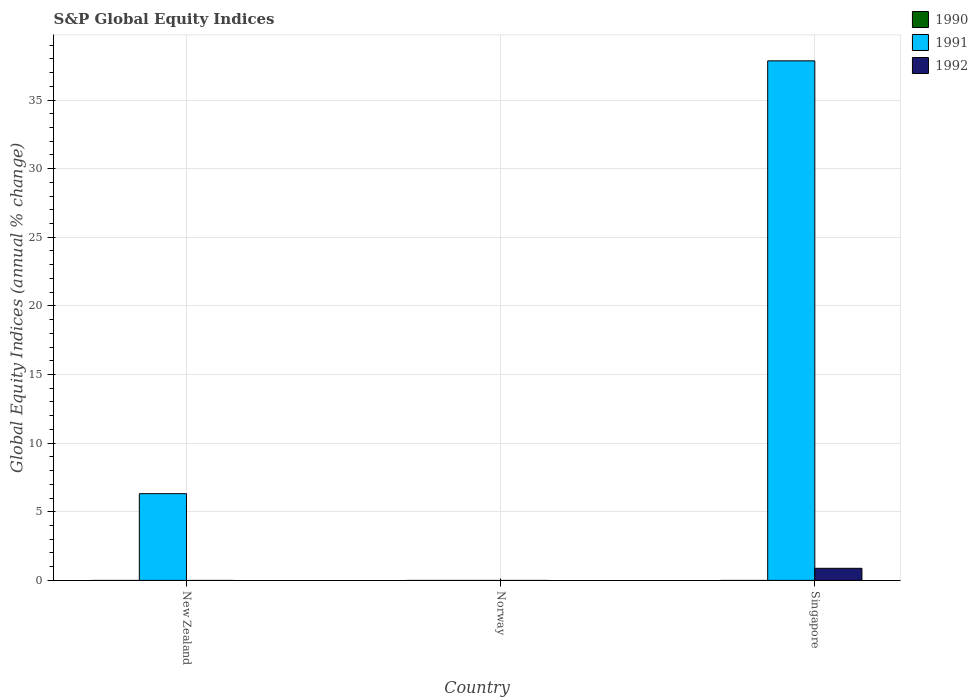How many different coloured bars are there?
Offer a very short reply. 2. Are the number of bars on each tick of the X-axis equal?
Keep it short and to the point. No. How many bars are there on the 3rd tick from the left?
Offer a very short reply. 2. How many bars are there on the 3rd tick from the right?
Offer a very short reply. 1. What is the label of the 2nd group of bars from the left?
Provide a short and direct response. Norway. In how many cases, is the number of bars for a given country not equal to the number of legend labels?
Your answer should be compact. 3. Across all countries, what is the maximum global equity indices in 1992?
Your answer should be compact. 0.88. In which country was the global equity indices in 1991 maximum?
Provide a succinct answer. Singapore. What is the total global equity indices in 1991 in the graph?
Your answer should be compact. 44.17. What is the difference between the global equity indices in 1991 in New Zealand and the global equity indices in 1990 in Singapore?
Offer a terse response. 6.32. What is the average global equity indices in 1992 per country?
Your answer should be very brief. 0.29. What is the difference between the global equity indices of/in 1992 and global equity indices of/in 1991 in Singapore?
Your answer should be compact. -36.97. What is the difference between the highest and the lowest global equity indices in 1992?
Your response must be concise. 0.88. In how many countries, is the global equity indices in 1992 greater than the average global equity indices in 1992 taken over all countries?
Provide a succinct answer. 1. Is the sum of the global equity indices in 1991 in New Zealand and Singapore greater than the maximum global equity indices in 1990 across all countries?
Provide a short and direct response. Yes. Are all the bars in the graph horizontal?
Give a very brief answer. No. Are the values on the major ticks of Y-axis written in scientific E-notation?
Give a very brief answer. No. Does the graph contain grids?
Ensure brevity in your answer.  Yes. Where does the legend appear in the graph?
Offer a very short reply. Top right. How many legend labels are there?
Offer a very short reply. 3. How are the legend labels stacked?
Give a very brief answer. Vertical. What is the title of the graph?
Provide a succinct answer. S&P Global Equity Indices. Does "1972" appear as one of the legend labels in the graph?
Keep it short and to the point. No. What is the label or title of the Y-axis?
Make the answer very short. Global Equity Indices (annual % change). What is the Global Equity Indices (annual % change) of 1991 in New Zealand?
Provide a succinct answer. 6.32. What is the Global Equity Indices (annual % change) in 1992 in New Zealand?
Your answer should be very brief. 0. What is the Global Equity Indices (annual % change) of 1990 in Norway?
Provide a succinct answer. 0. What is the Global Equity Indices (annual % change) in 1991 in Norway?
Offer a terse response. 0. What is the Global Equity Indices (annual % change) of 1992 in Norway?
Your answer should be compact. 0. What is the Global Equity Indices (annual % change) of 1991 in Singapore?
Ensure brevity in your answer.  37.85. What is the Global Equity Indices (annual % change) in 1992 in Singapore?
Keep it short and to the point. 0.88. Across all countries, what is the maximum Global Equity Indices (annual % change) in 1991?
Provide a succinct answer. 37.85. Across all countries, what is the maximum Global Equity Indices (annual % change) in 1992?
Your response must be concise. 0.88. What is the total Global Equity Indices (annual % change) of 1990 in the graph?
Your answer should be very brief. 0. What is the total Global Equity Indices (annual % change) in 1991 in the graph?
Make the answer very short. 44.17. What is the total Global Equity Indices (annual % change) in 1992 in the graph?
Make the answer very short. 0.88. What is the difference between the Global Equity Indices (annual % change) of 1991 in New Zealand and that in Singapore?
Your answer should be compact. -31.53. What is the difference between the Global Equity Indices (annual % change) of 1991 in New Zealand and the Global Equity Indices (annual % change) of 1992 in Singapore?
Offer a terse response. 5.44. What is the average Global Equity Indices (annual % change) of 1990 per country?
Provide a short and direct response. 0. What is the average Global Equity Indices (annual % change) of 1991 per country?
Provide a short and direct response. 14.72. What is the average Global Equity Indices (annual % change) of 1992 per country?
Your answer should be compact. 0.29. What is the difference between the Global Equity Indices (annual % change) in 1991 and Global Equity Indices (annual % change) in 1992 in Singapore?
Keep it short and to the point. 36.97. What is the ratio of the Global Equity Indices (annual % change) in 1991 in New Zealand to that in Singapore?
Your answer should be very brief. 0.17. What is the difference between the highest and the lowest Global Equity Indices (annual % change) of 1991?
Your answer should be very brief. 37.85. What is the difference between the highest and the lowest Global Equity Indices (annual % change) in 1992?
Provide a succinct answer. 0.88. 